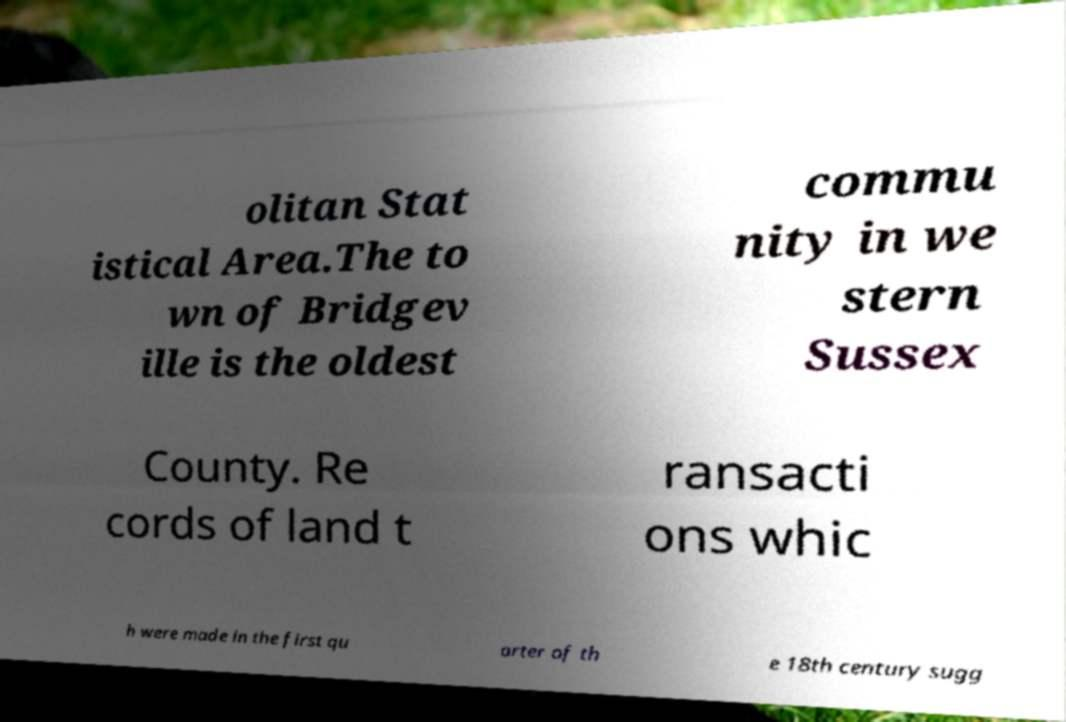Can you accurately transcribe the text from the provided image for me? olitan Stat istical Area.The to wn of Bridgev ille is the oldest commu nity in we stern Sussex County. Re cords of land t ransacti ons whic h were made in the first qu arter of th e 18th century sugg 